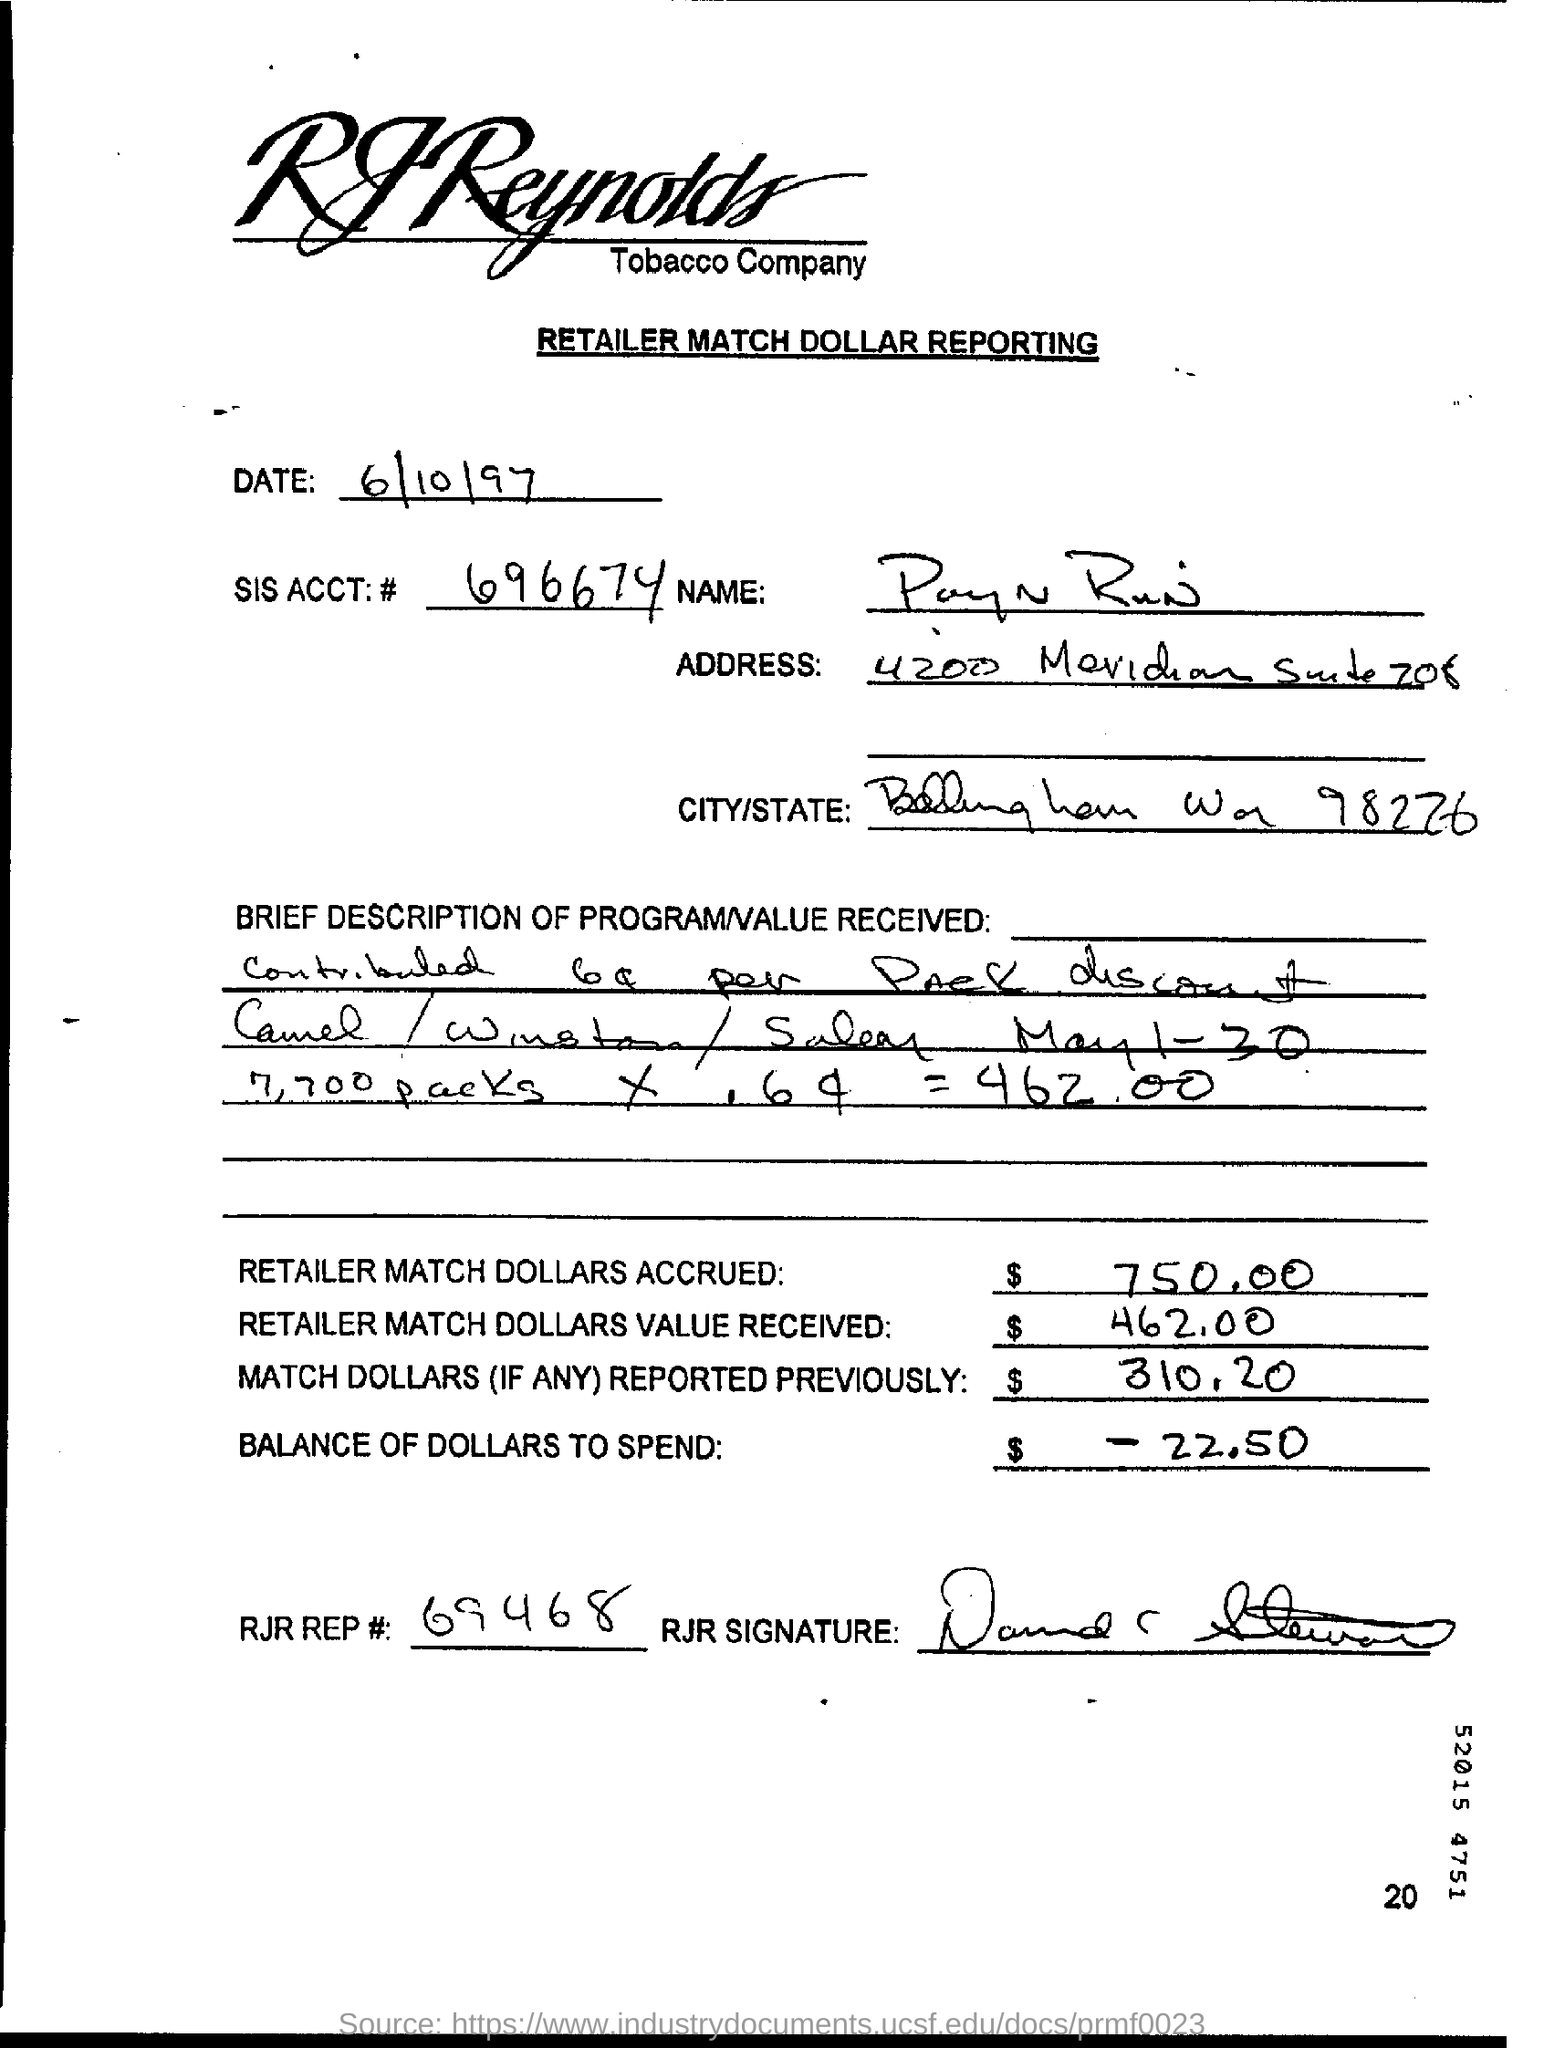Highlight a few significant elements in this photo. The total value of retailer match dollars accrued is $750.00. What is the SIS ACCT: # number? It is 696674... The RJP REP# is 69468. The retailer match value received is $462.00. 